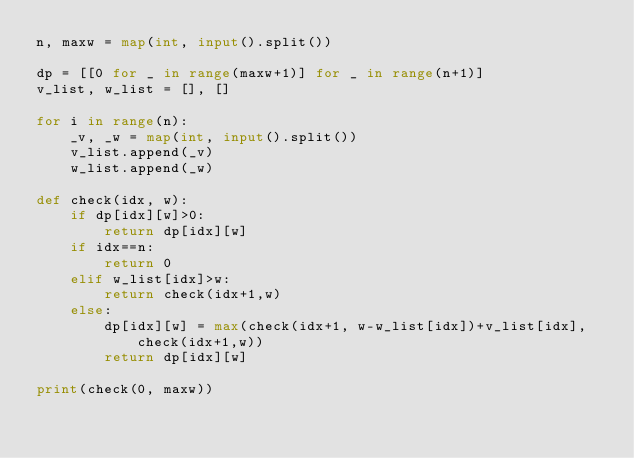Convert code to text. <code><loc_0><loc_0><loc_500><loc_500><_Python_>n, maxw = map(int, input().split())

dp = [[0 for _ in range(maxw+1)] for _ in range(n+1)]
v_list, w_list = [], []

for i in range(n):
    _v, _w = map(int, input().split())
    v_list.append(_v)
    w_list.append(_w)

def check(idx, w):
    if dp[idx][w]>0:
        return dp[idx][w]
    if idx==n:
        return 0
    elif w_list[idx]>w:
        return check(idx+1,w)
    else:
        dp[idx][w] = max(check(idx+1, w-w_list[idx])+v_list[idx], check(idx+1,w))
        return dp[idx][w]

print(check(0, maxw))</code> 